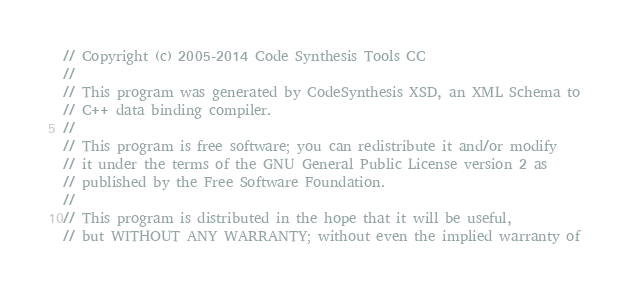Convert code to text. <code><loc_0><loc_0><loc_500><loc_500><_C++_>// Copyright (c) 2005-2014 Code Synthesis Tools CC
//
// This program was generated by CodeSynthesis XSD, an XML Schema to
// C++ data binding compiler.
//
// This program is free software; you can redistribute it and/or modify
// it under the terms of the GNU General Public License version 2 as
// published by the Free Software Foundation.
//
// This program is distributed in the hope that it will be useful,
// but WITHOUT ANY WARRANTY; without even the implied warranty of</code> 